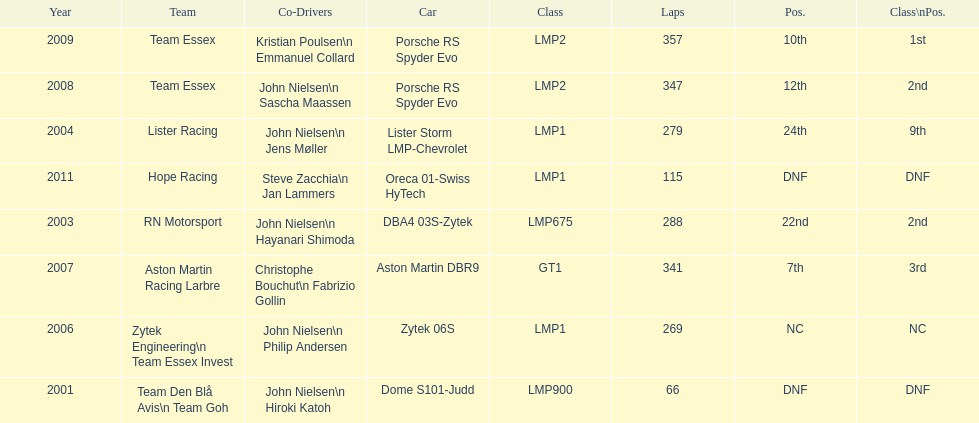What is the amount races that were competed in? 8. 